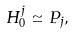Convert formula to latex. <formula><loc_0><loc_0><loc_500><loc_500>H ^ { j } _ { 0 } \simeq P _ { j } ,</formula> 